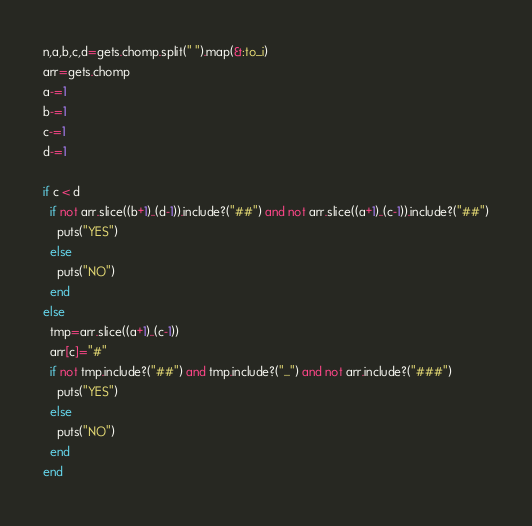<code> <loc_0><loc_0><loc_500><loc_500><_Ruby_>n,a,b,c,d=gets.chomp.split(" ").map(&:to_i)
arr=gets.chomp
a-=1
b-=1
c-=1
d-=1

if c < d
  if not arr.slice((b+1)..(d-1)).include?("##") and not arr.slice((a+1)..(c-1)).include?("##")
    puts("YES")
  else
    puts("NO")
  end
else
  tmp=arr.slice((a+1)..(c-1))
  arr[c]="#"
  if not tmp.include?("##") and tmp.include?("...") and not arr.include?("###")
    puts("YES")
  else
    puts("NO")
  end
end
</code> 